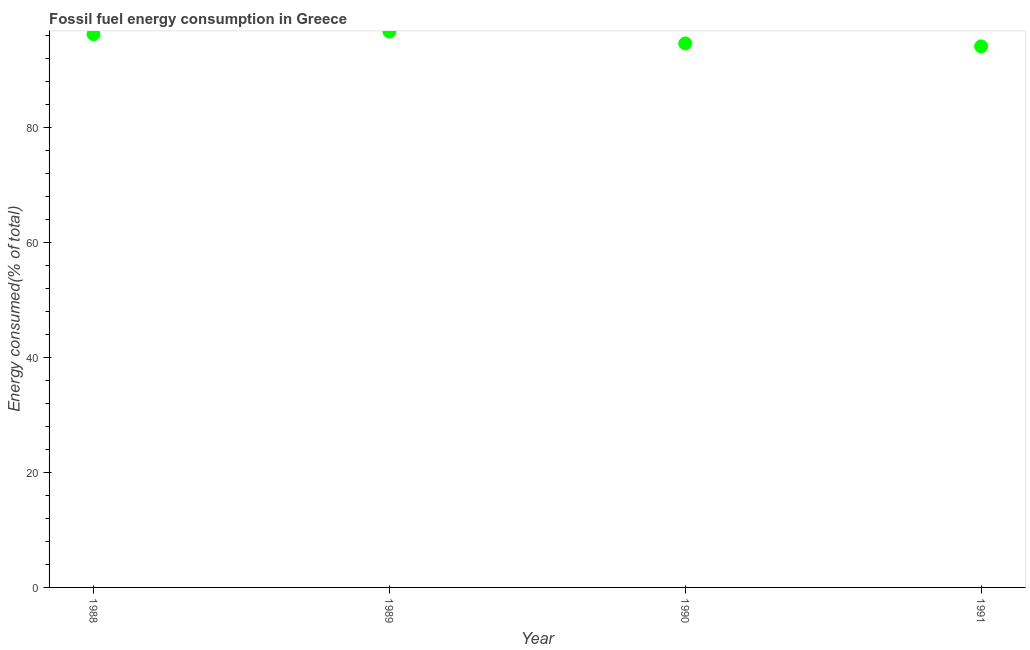What is the fossil fuel energy consumption in 1990?
Give a very brief answer. 94.56. Across all years, what is the maximum fossil fuel energy consumption?
Offer a very short reply. 96.63. Across all years, what is the minimum fossil fuel energy consumption?
Your answer should be compact. 94.06. What is the sum of the fossil fuel energy consumption?
Offer a very short reply. 381.43. What is the difference between the fossil fuel energy consumption in 1989 and 1990?
Keep it short and to the point. 2.07. What is the average fossil fuel energy consumption per year?
Give a very brief answer. 95.36. What is the median fossil fuel energy consumption?
Ensure brevity in your answer.  95.37. Do a majority of the years between 1990 and 1991 (inclusive) have fossil fuel energy consumption greater than 44 %?
Provide a succinct answer. Yes. What is the ratio of the fossil fuel energy consumption in 1989 to that in 1990?
Provide a succinct answer. 1.02. What is the difference between the highest and the second highest fossil fuel energy consumption?
Offer a terse response. 0.45. What is the difference between the highest and the lowest fossil fuel energy consumption?
Make the answer very short. 2.57. Does the fossil fuel energy consumption monotonically increase over the years?
Your answer should be very brief. No. How many years are there in the graph?
Your answer should be compact. 4. What is the difference between two consecutive major ticks on the Y-axis?
Your answer should be very brief. 20. Are the values on the major ticks of Y-axis written in scientific E-notation?
Your answer should be compact. No. Does the graph contain any zero values?
Offer a terse response. No. Does the graph contain grids?
Your answer should be very brief. No. What is the title of the graph?
Your answer should be very brief. Fossil fuel energy consumption in Greece. What is the label or title of the Y-axis?
Offer a terse response. Energy consumed(% of total). What is the Energy consumed(% of total) in 1988?
Your answer should be very brief. 96.18. What is the Energy consumed(% of total) in 1989?
Your response must be concise. 96.63. What is the Energy consumed(% of total) in 1990?
Give a very brief answer. 94.56. What is the Energy consumed(% of total) in 1991?
Ensure brevity in your answer.  94.06. What is the difference between the Energy consumed(% of total) in 1988 and 1989?
Offer a very short reply. -0.45. What is the difference between the Energy consumed(% of total) in 1988 and 1990?
Your answer should be very brief. 1.61. What is the difference between the Energy consumed(% of total) in 1988 and 1991?
Ensure brevity in your answer.  2.12. What is the difference between the Energy consumed(% of total) in 1989 and 1990?
Give a very brief answer. 2.07. What is the difference between the Energy consumed(% of total) in 1989 and 1991?
Your answer should be compact. 2.57. What is the difference between the Energy consumed(% of total) in 1990 and 1991?
Make the answer very short. 0.51. What is the ratio of the Energy consumed(% of total) in 1989 to that in 1991?
Ensure brevity in your answer.  1.03. 